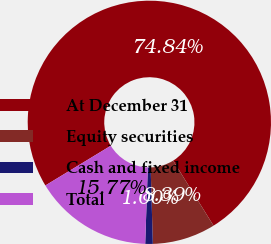<chart> <loc_0><loc_0><loc_500><loc_500><pie_chart><fcel>At December 31<fcel>Equity securities<fcel>Cash and fixed income<fcel>Total<nl><fcel>74.84%<fcel>8.39%<fcel>1.0%<fcel>15.77%<nl></chart> 